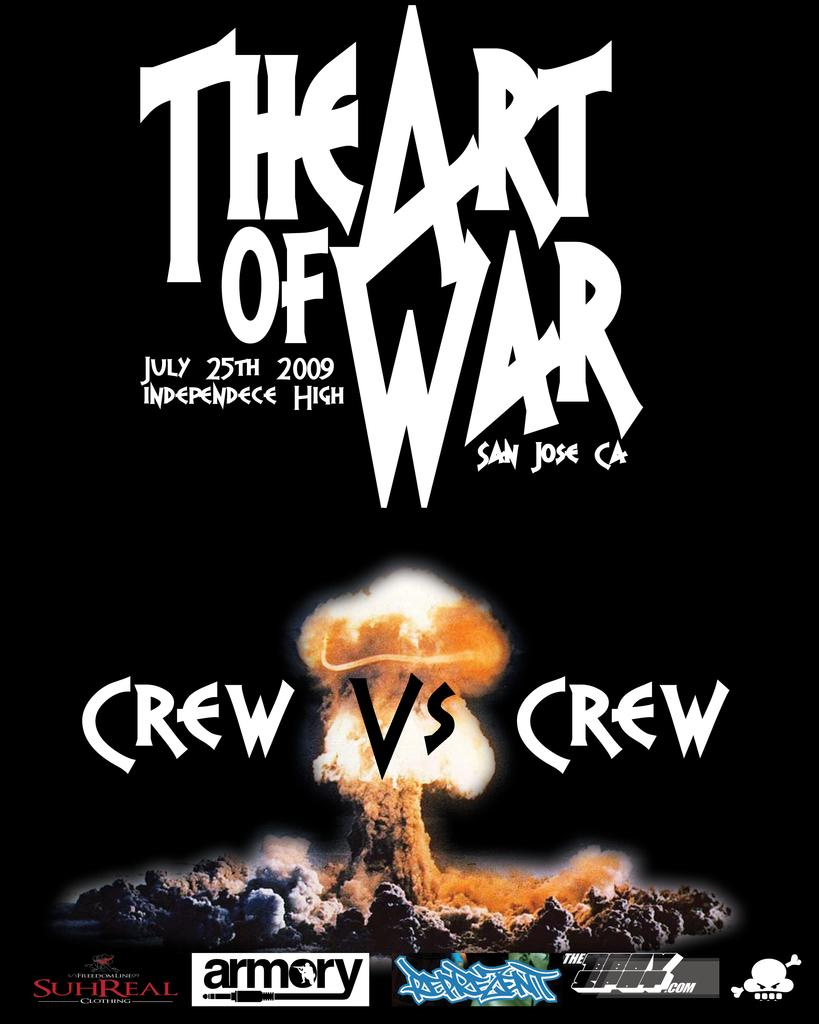What is present in the image that contains both text and images? There is a poster in the image that contains text and images. Can you describe the content of the poster in the image? The poster contains text and images, but the specific content cannot be determined from the provided facts. How many hens are depicted on the poster in the image? There is no hen present on the poster in the image, as the provided facts only mention text and images. 